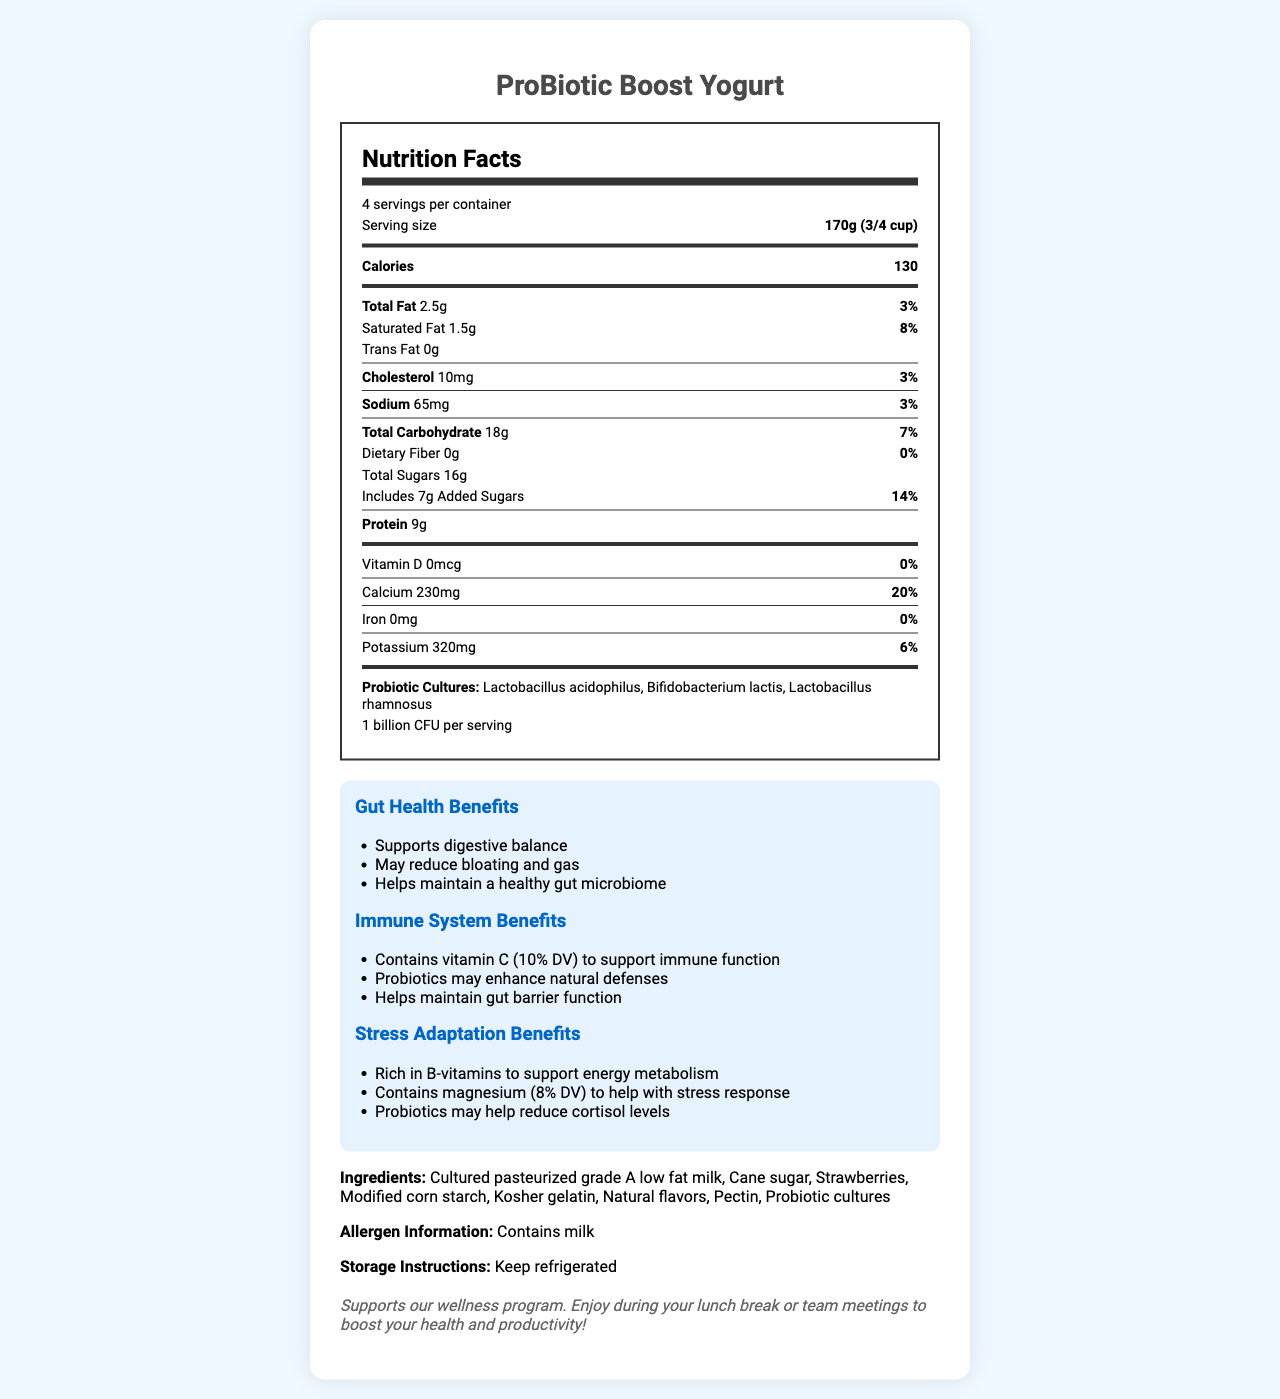how many servings are in the container? The document states that there are 4 servings per container.
Answer: 4 servings what is the serving size for ProBiotic Boost Yogurt? The serving size information is clearly indicated as "170g (3/4 cup)".
Answer: 170g (3/4 cup) how many calories are in a single serving? The calorie information per serving is specified in the document as 130 calories.
Answer: 130 calories how much total fat is there per serving? The document lists the total fat content as 2.5g per serving.
Answer: 2.5g what percentage of the daily value of calcium does one serving provide? The document states that one serving provides 20% of the daily value for calcium.
Answer: 20% what is the amount of added sugars in a single serving? The document shows that each serving includes 7g of added sugars.
Answer: 7g how many grams of protein are in each serving? The amount of protein per serving is listed as 9g.
Answer: 9g which probiotic cultures are included in ProBiotic Boost Yogurt? A. Lactobacillus acidophilus and Bifidobacterium lactis B. Bifidobacterium lactis and Lactobacillus rhamnosus C. Lactobacillus acidophilus, Bifidobacterium lactis, and Lactobacillus rhamnosus D. Lactobacillus acidophilus only The document lists the probiotic cultures as Lactobacillus acidophilus, Bifidobacterium lactis, and Lactobacillus rhamnosus.
Answer: C how much sodium is in each serving? A. 10mg B. 65mg C. 3% D. 20% Sodium content per serving is specified in the document as 65mg.
Answer: B are there any ingredients that may cause allergies? The document states that the product contains milk, which is a common allergen.
Answer: Yes does the yogurt support gut health? The document outlines several gut health benefits, including supporting digestive balance and maintaining a healthy gut microbiome.
Answer: Yes describe the main idea of the document. The document comprehensively outlines the nutritional facts, ingredients, health benefits, and storage instructions for ProBiotic Boost Yogurt, making it clear what the product offers.
Answer: The document provides detailed nutrition information for ProBiotic Boost Yogurt, highlighting its serving size, nutritional content, probiotics, benefits for gut health, immune system, and stress adaptation, as well as storage instructions and allergen information. what is the company's policy note related to the yogurt? The document contains a note that encourages consumption during breaks or meetings as part of the company's wellness program.
Answer: Supports our wellness program. Enjoy during your lunch break or team meetings to boost your health and productivity! can it be determined if this yogurt is suitable for vegetarians? The document does not provide information regarding whether the ingredients and probiotics are derived from non-animal sources, so it cannot be determined if the yogurt is suitable for vegetarians.
Answer: Not enough information 